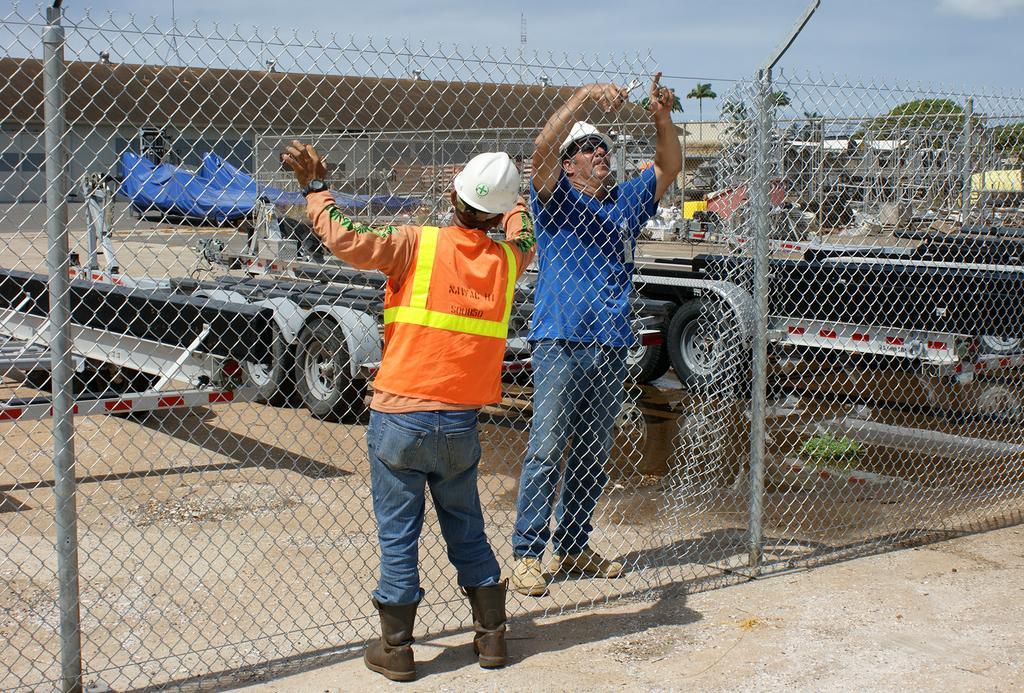Can you describe this image briefly? In this image we can see two persons wearing the helmets and standing on the land. We can also see the fence and behind the fence we can see some vehicles. There is also a building and trees. Sky is also visible. 